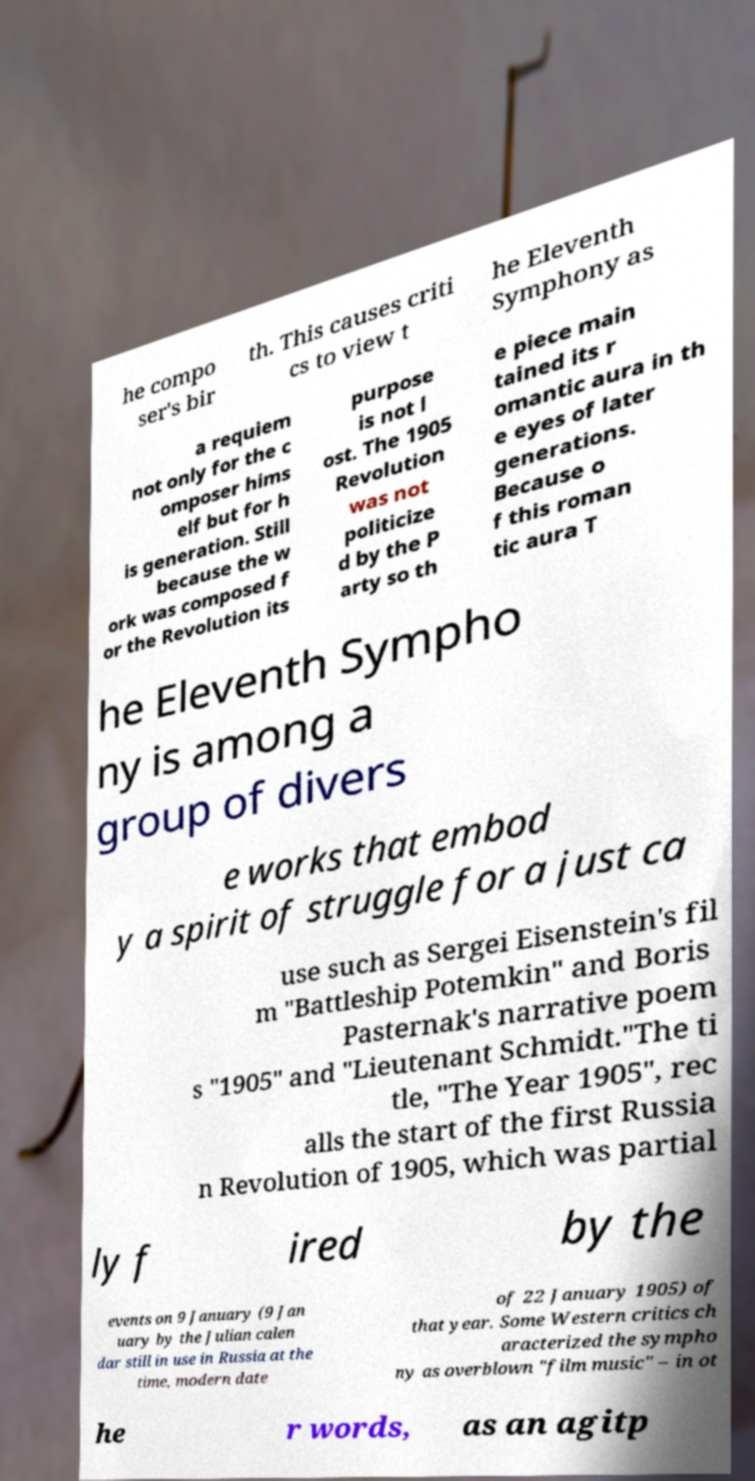What messages or text are displayed in this image? I need them in a readable, typed format. he compo ser's bir th. This causes criti cs to view t he Eleventh Symphony as a requiem not only for the c omposer hims elf but for h is generation. Still because the w ork was composed f or the Revolution its purpose is not l ost. The 1905 Revolution was not politicize d by the P arty so th e piece main tained its r omantic aura in th e eyes of later generations. Because o f this roman tic aura T he Eleventh Sympho ny is among a group of divers e works that embod y a spirit of struggle for a just ca use such as Sergei Eisenstein's fil m "Battleship Potemkin" and Boris Pasternak's narrative poem s "1905" and "Lieutenant Schmidt."The ti tle, "The Year 1905", rec alls the start of the first Russia n Revolution of 1905, which was partial ly f ired by the events on 9 January (9 Jan uary by the Julian calen dar still in use in Russia at the time, modern date of 22 January 1905) of that year. Some Western critics ch aracterized the sympho ny as overblown "film music" – in ot he r words, as an agitp 